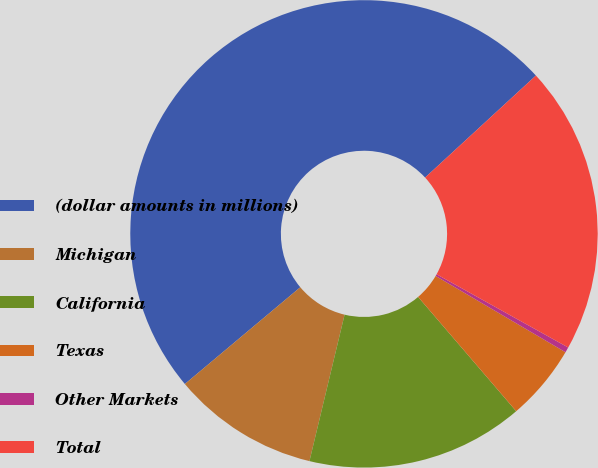<chart> <loc_0><loc_0><loc_500><loc_500><pie_chart><fcel>(dollar amounts in millions)<fcel>Michigan<fcel>California<fcel>Texas<fcel>Other Markets<fcel>Total<nl><fcel>49.27%<fcel>10.15%<fcel>15.04%<fcel>5.26%<fcel>0.37%<fcel>19.93%<nl></chart> 